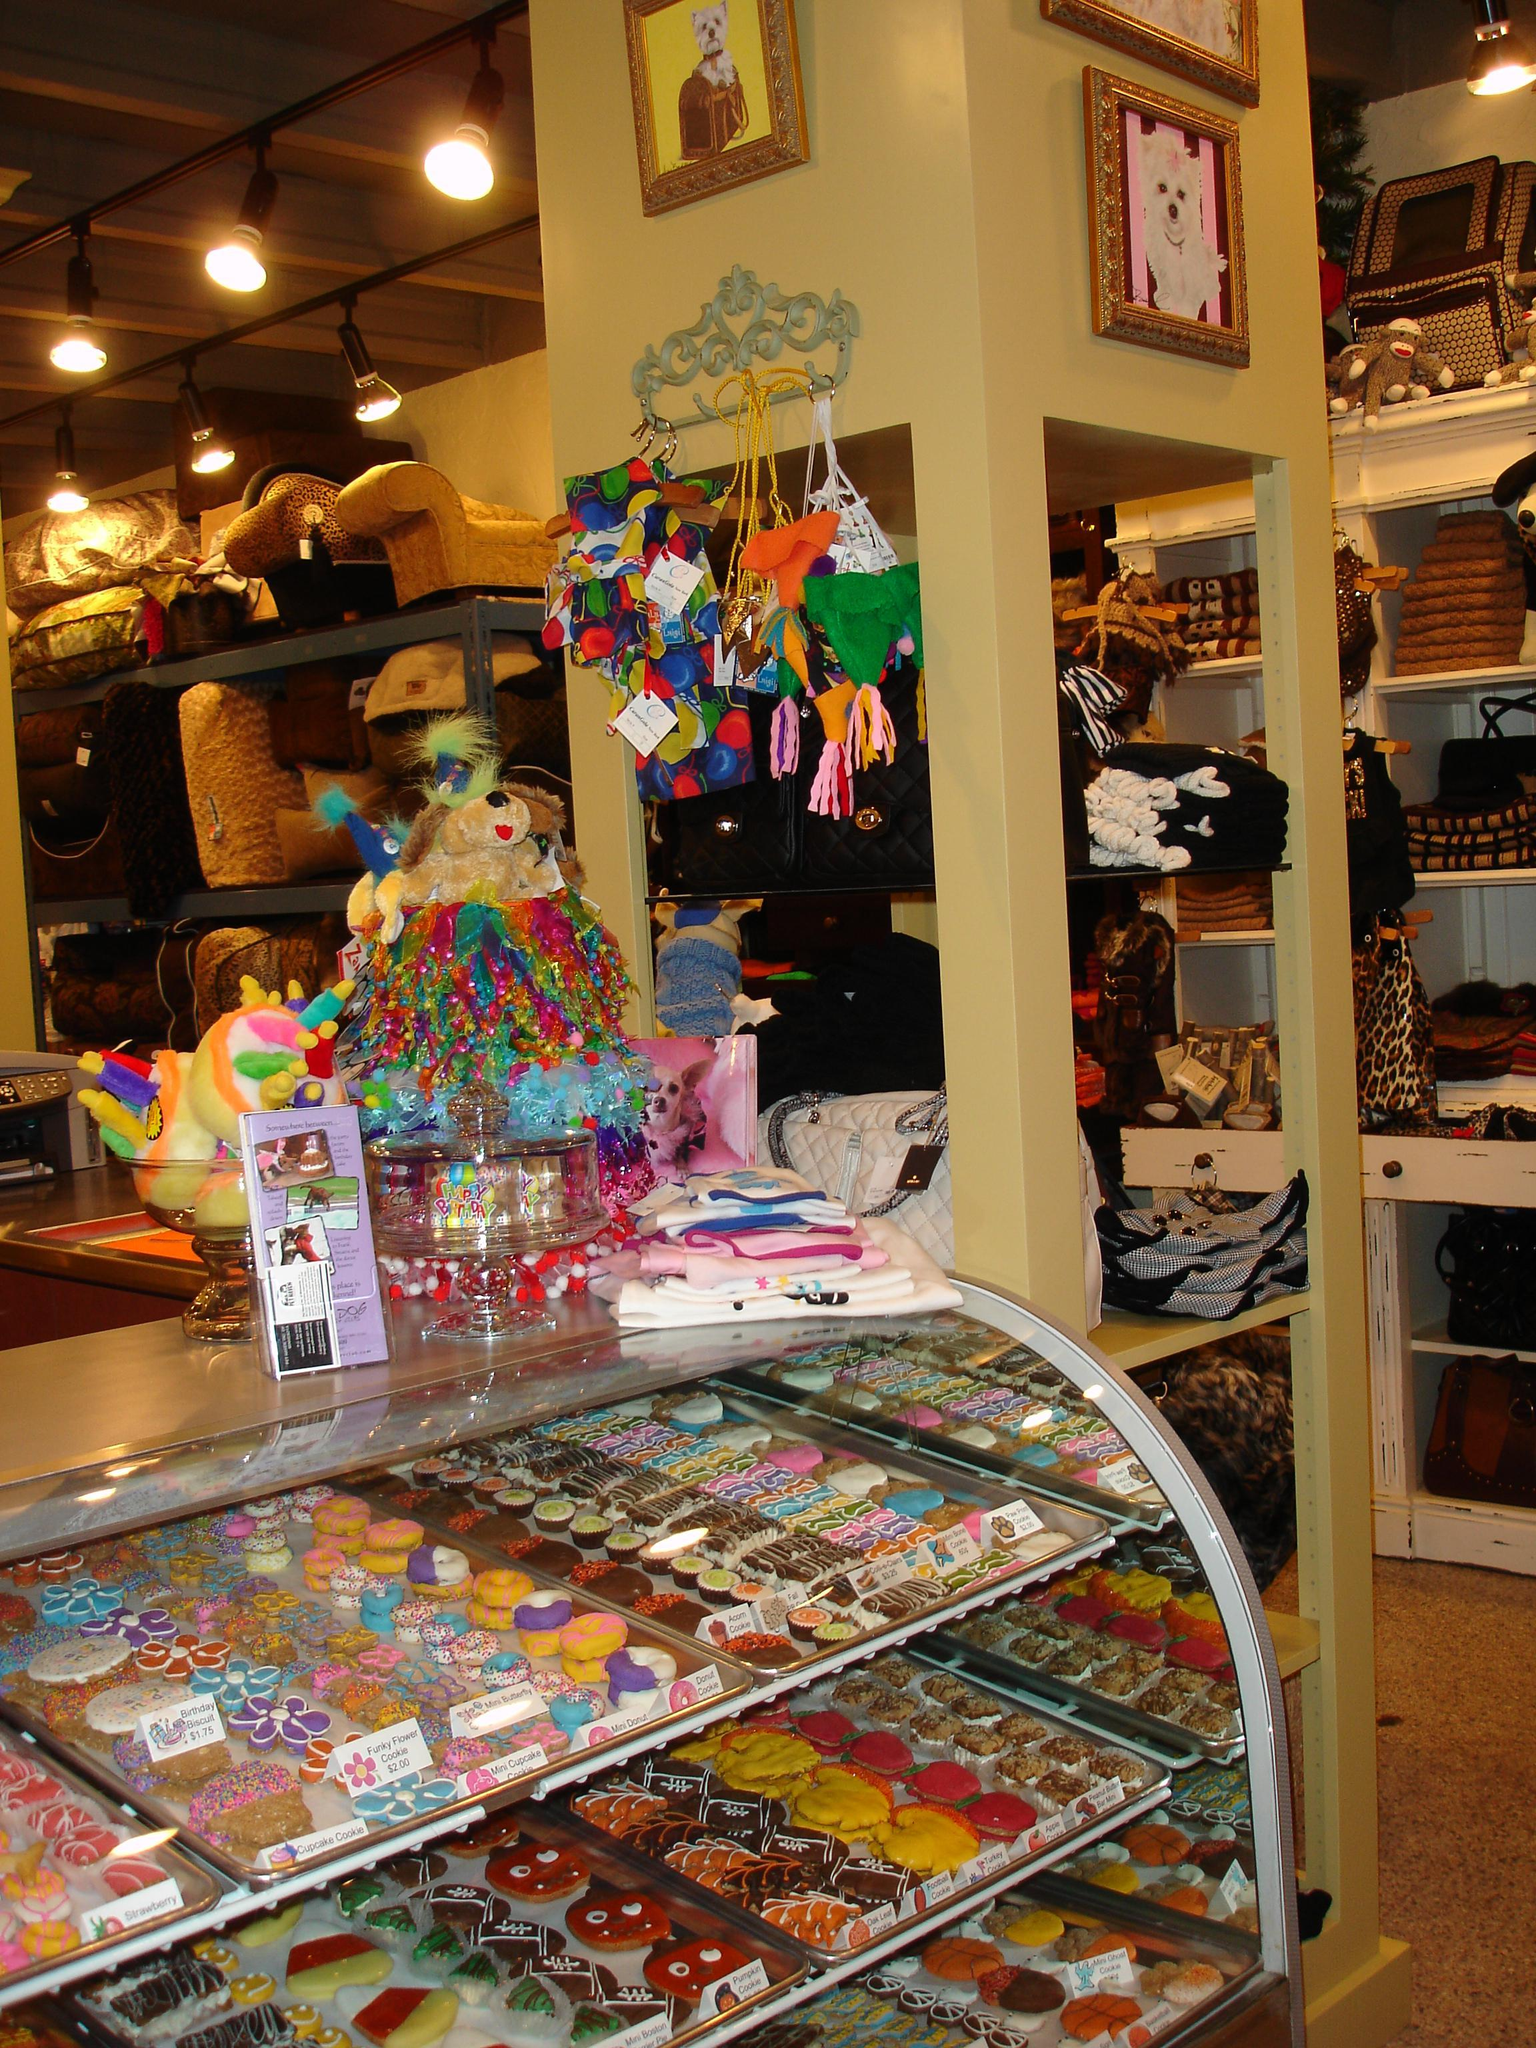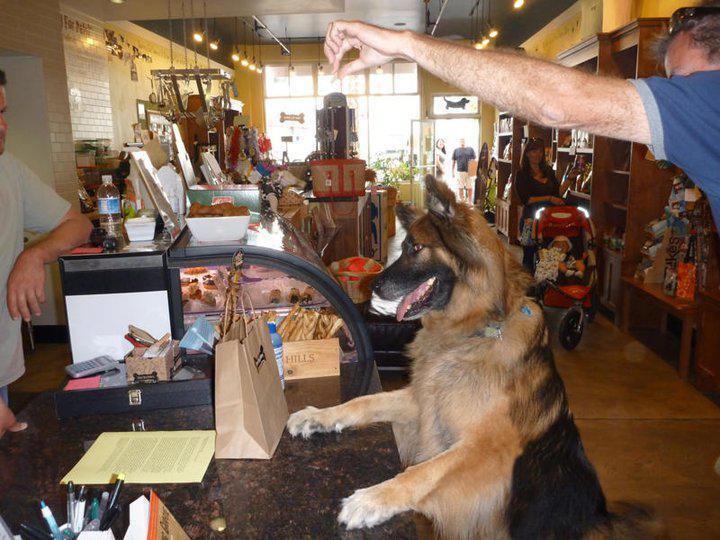The first image is the image on the left, the second image is the image on the right. Considering the images on both sides, is "An image shows a golden-haired right-facing dog standing with its front paws propped atop a wood-front counter." valid? Answer yes or no. No. The first image is the image on the left, the second image is the image on the right. Given the left and right images, does the statement "A dog has its front paws on the counter in the image on the right." hold true? Answer yes or no. Yes. 